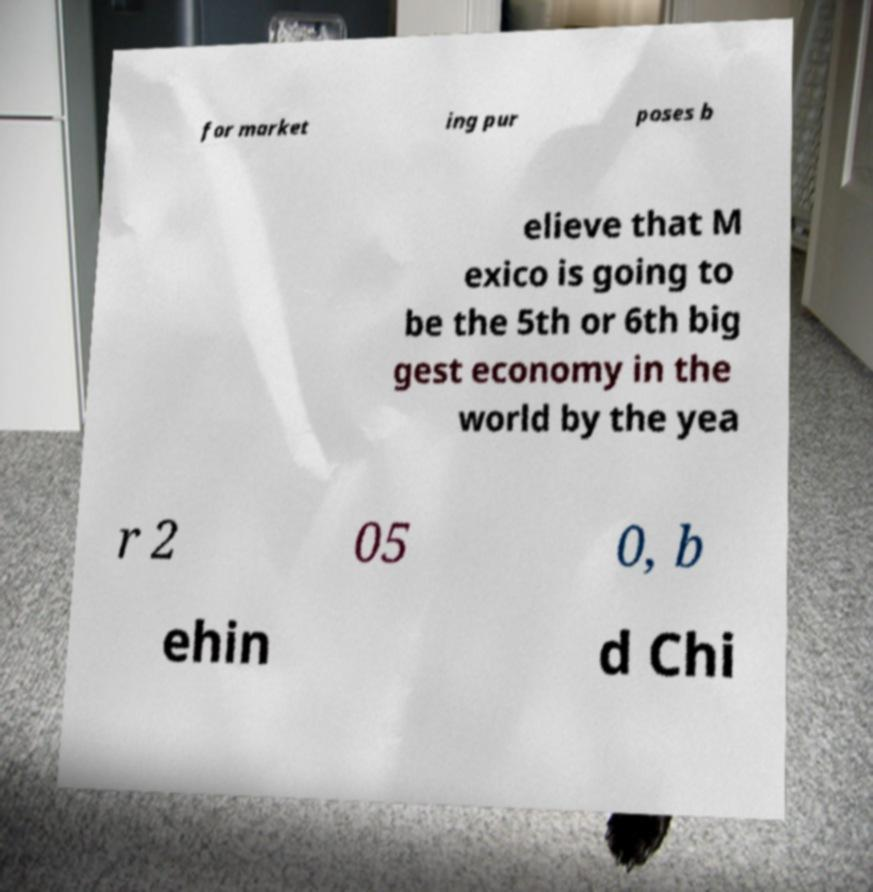There's text embedded in this image that I need extracted. Can you transcribe it verbatim? for market ing pur poses b elieve that M exico is going to be the 5th or 6th big gest economy in the world by the yea r 2 05 0, b ehin d Chi 